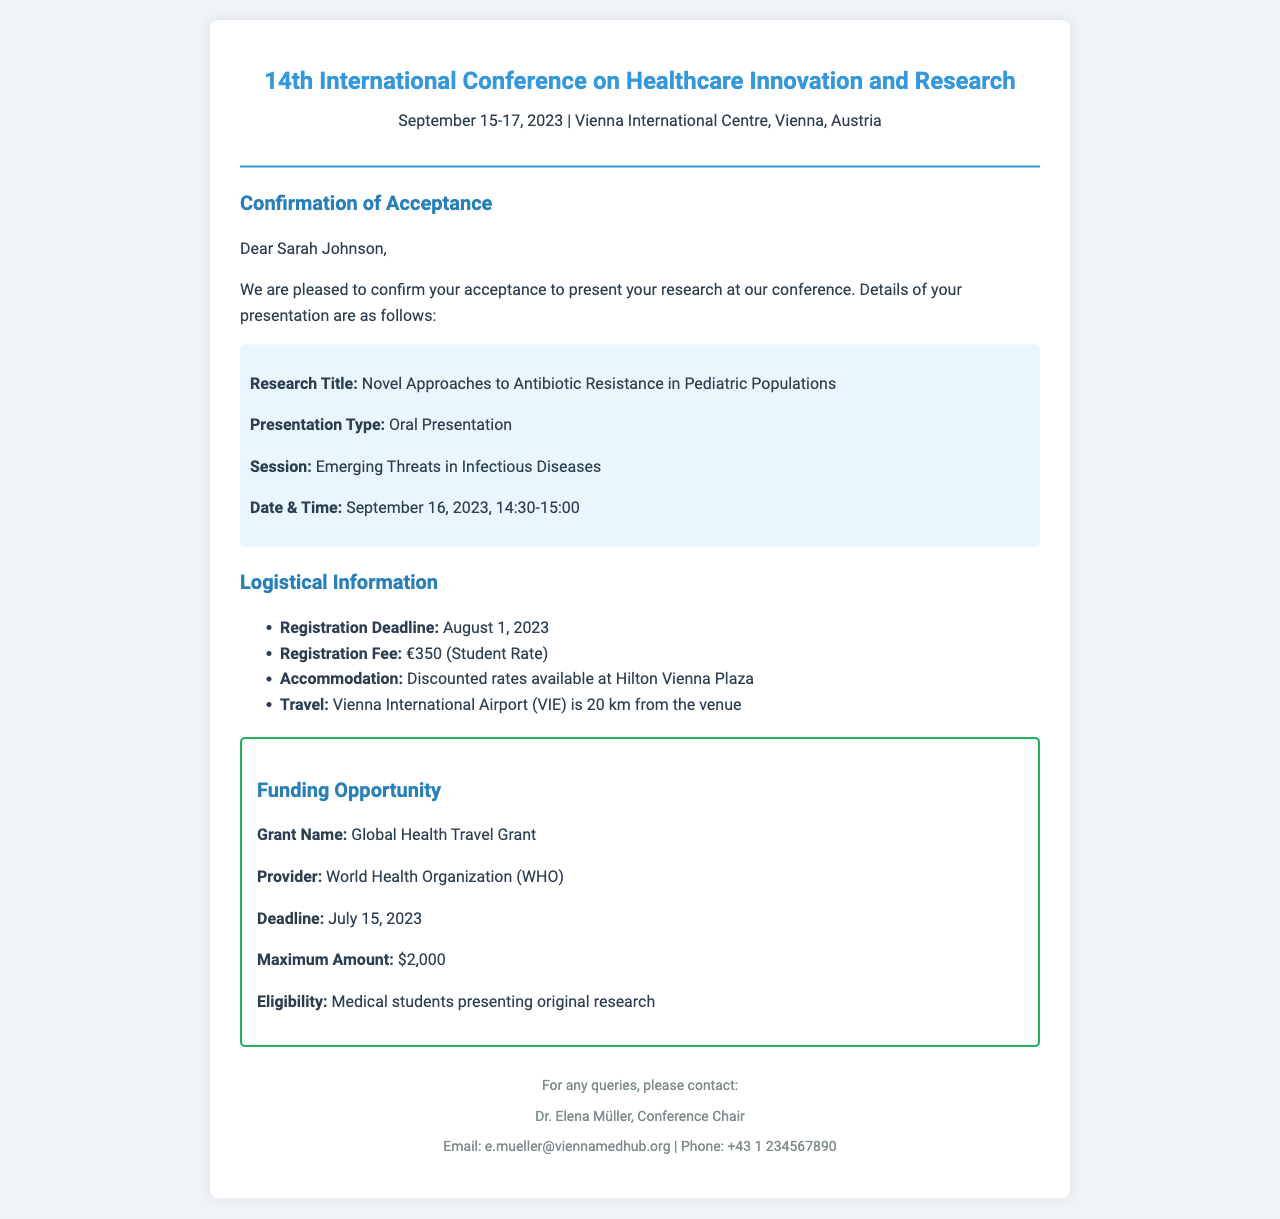What is the title of the research? The title of the research is mentioned in the presentation details section.
Answer: Novel Approaches to Antibiotic Resistance in Pediatric Populations When will the presentation take place? The date and time of the presentation are specified in the details section.
Answer: September 16, 2023, 14:30-15:00 What is the registration deadline? The registration deadline is explicitly stated under logistical information.
Answer: August 1, 2023 What is the registration fee? The registration fee is included in the logistical section of the fax.
Answer: €350 (Student Rate) What is the maximum amount for the Global Health Travel Grant? The maximum amount is specified in the funding opportunity section.
Answer: $2,000 Who is the conference chair? The conference chair's name is mentioned in the footer of the document.
Answer: Dr. Elena Müller What is the email address for inquiries? The contact email for any questions is provided in the footer section.
Answer: e.mueller@viennamedhub.org What is the accommodation option mentioned? The accommodation option available is noted in the logistical information section.
Answer: Hilton Vienna Plaza 